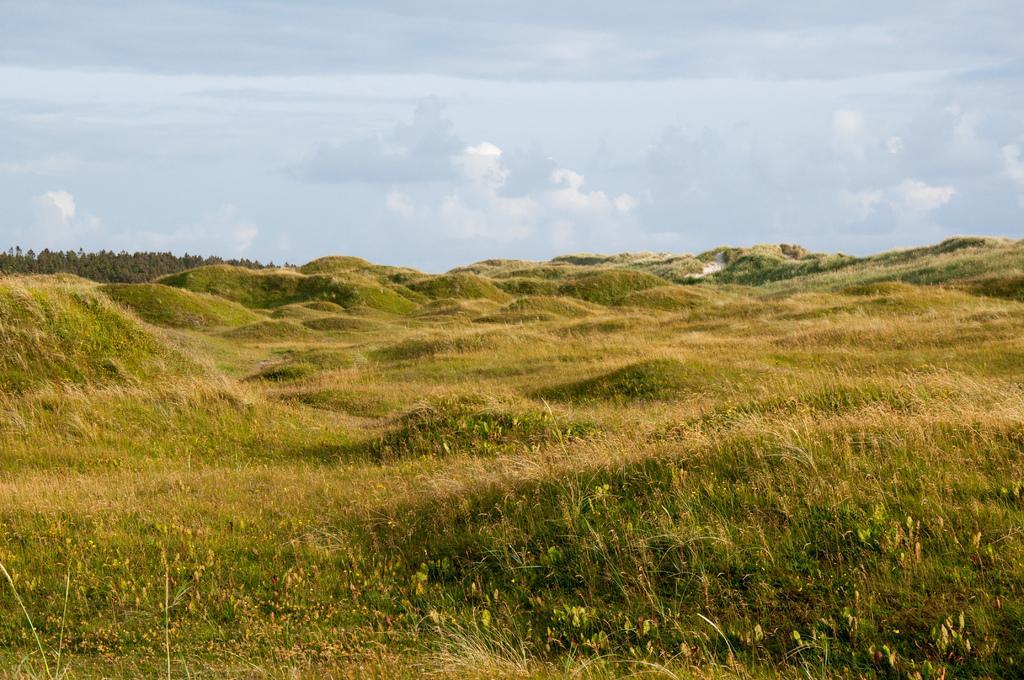Could you give a brief overview of what you see in this image? In this image there are grass , plants, trees,sky. 